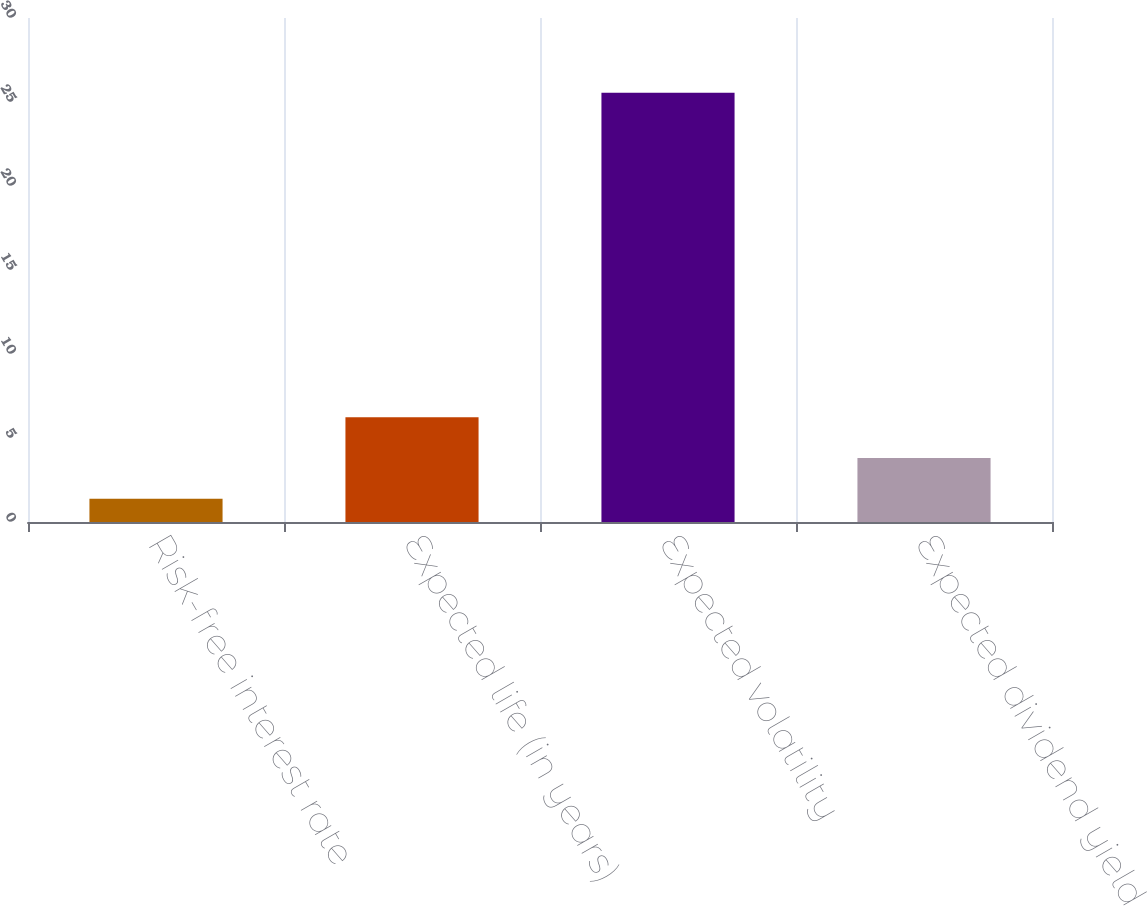Convert chart. <chart><loc_0><loc_0><loc_500><loc_500><bar_chart><fcel>Risk-free interest rate<fcel>Expected life (in years)<fcel>Expected volatility<fcel>Expected dividend yield<nl><fcel>1.39<fcel>6.23<fcel>25.55<fcel>3.81<nl></chart> 